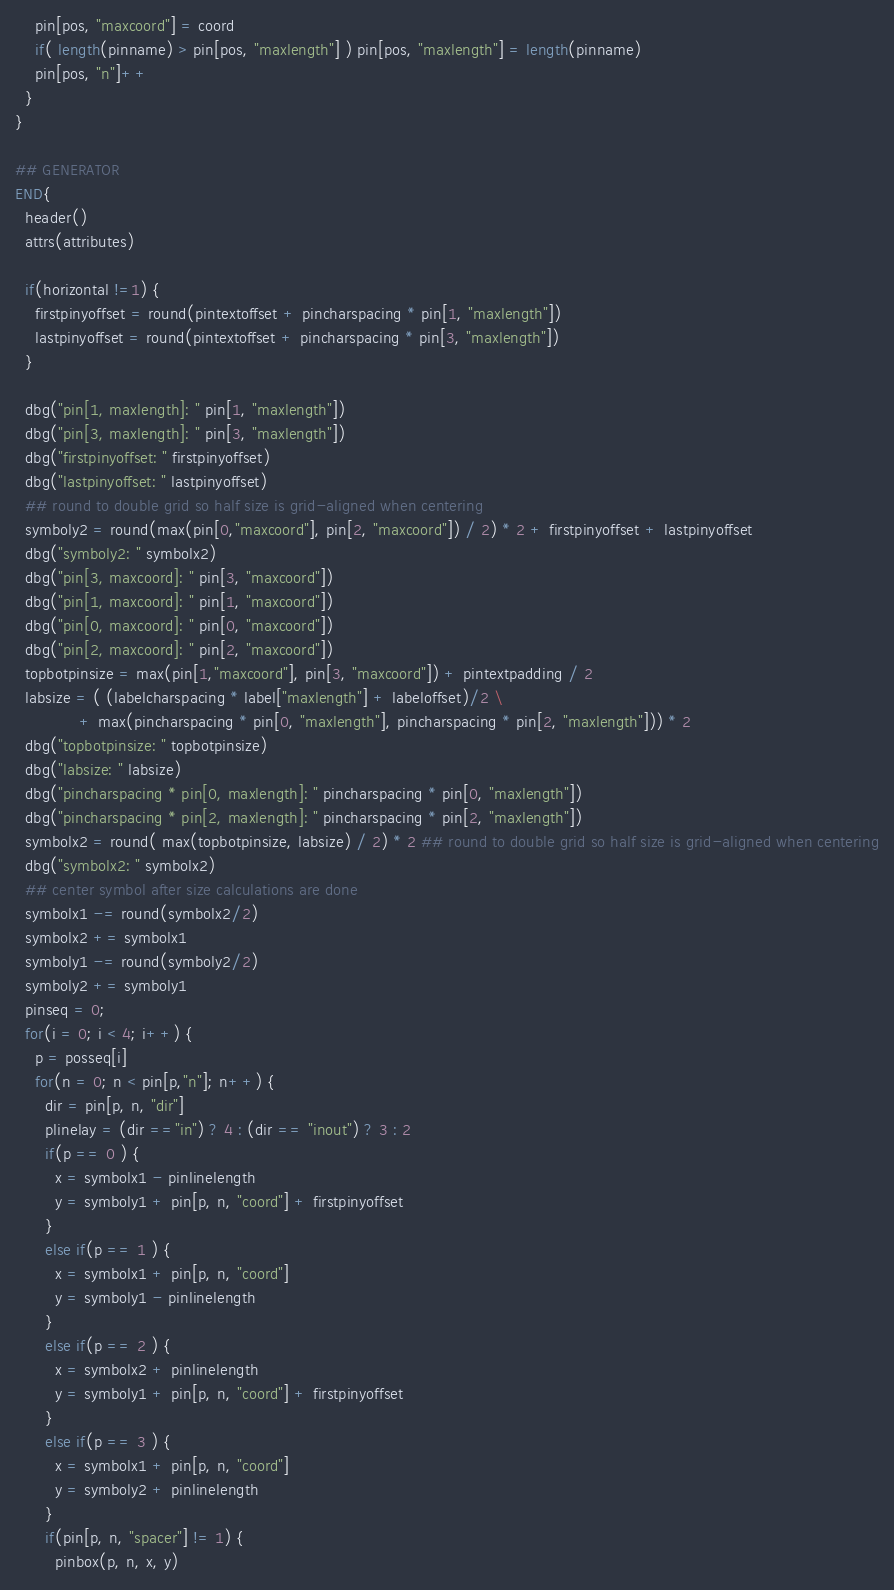<code> <loc_0><loc_0><loc_500><loc_500><_Awk_>    pin[pos, "maxcoord"] = coord
    if( length(pinname) > pin[pos, "maxlength"] ) pin[pos, "maxlength"] = length(pinname)
    pin[pos, "n"]++
  }
}

## GENERATOR
END{
  header()
  attrs(attributes)
 
  if(horizontal !=1) {
    firstpinyoffset = round(pintextoffset + pincharspacing * pin[1, "maxlength"])
    lastpinyoffset = round(pintextoffset + pincharspacing * pin[3, "maxlength"])
  }
 
  dbg("pin[1, maxlength]: " pin[1, "maxlength"])
  dbg("pin[3, maxlength]: " pin[3, "maxlength"])
  dbg("firstpinyoffset: " firstpinyoffset)
  dbg("lastpinyoffset: " lastpinyoffset)
  ## round to double grid so half size is grid-aligned when centering
  symboly2 = round(max(pin[0,"maxcoord"], pin[2, "maxcoord"]) / 2) * 2 + firstpinyoffset + lastpinyoffset
  dbg("symboly2: " symbolx2)
  dbg("pin[3, maxcoord]: " pin[3, "maxcoord"])
  dbg("pin[1, maxcoord]: " pin[1, "maxcoord"])
  dbg("pin[0, maxcoord]: " pin[0, "maxcoord"])
  dbg("pin[2, maxcoord]: " pin[2, "maxcoord"])
  topbotpinsize = max(pin[1,"maxcoord"], pin[3, "maxcoord"]) + pintextpadding / 2
  labsize = ( (labelcharspacing * label["maxlength"] + labeloffset)/2 \
             + max(pincharspacing * pin[0, "maxlength"], pincharspacing * pin[2, "maxlength"])) * 2
  dbg("topbotpinsize: " topbotpinsize)
  dbg("labsize: " labsize)
  dbg("pincharspacing * pin[0, maxlength]: " pincharspacing * pin[0, "maxlength"])
  dbg("pincharspacing * pin[2, maxlength]: " pincharspacing * pin[2, "maxlength"])
  symbolx2 = round( max(topbotpinsize, labsize) / 2) * 2 ## round to double grid so half size is grid-aligned when centering
  dbg("symbolx2: " symbolx2)
  ## center symbol after size calculations are done
  symbolx1 -= round(symbolx2/2)
  symbolx2 += symbolx1
  symboly1 -= round(symboly2/2)
  symboly2 += symboly1
  pinseq = 0;
  for(i = 0; i < 4; i++) {
    p = posseq[i]
    for(n = 0; n < pin[p,"n"]; n++) {
      dir = pin[p, n, "dir"]
      plinelay = (dir =="in") ? 4 : (dir == "inout") ? 3 : 2
      if(p == 0 ) { 
        x = symbolx1 - pinlinelength
        y = symboly1 + pin[p, n, "coord"] + firstpinyoffset
      }
      else if(p == 1 ) { 
        x = symbolx1 + pin[p, n, "coord"]
        y = symboly1 - pinlinelength
      }
      else if(p == 2 ) { 
        x = symbolx2 + pinlinelength
        y = symboly1 + pin[p, n, "coord"] + firstpinyoffset
      }
      else if(p == 3 ) { 
        x = symbolx1 + pin[p, n, "coord"]
        y = symboly2 + pinlinelength
      }
      if(pin[p, n, "spacer"] != 1) {
        pinbox(p, n, x, y)</code> 